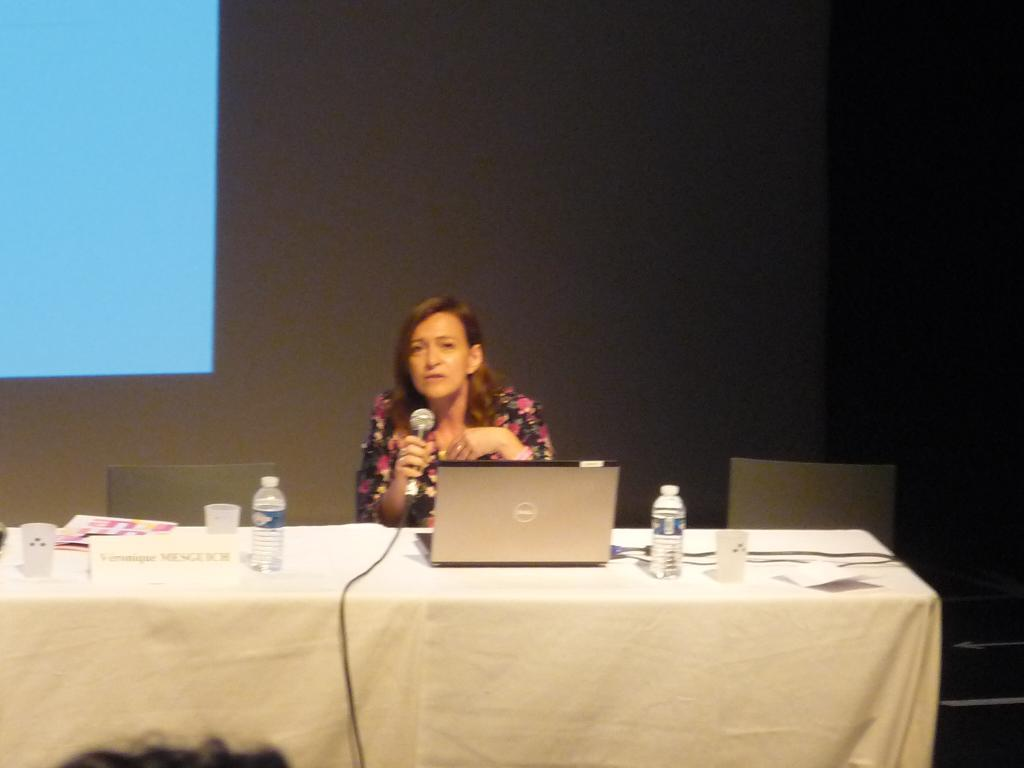What is the person in the image doing? The person is holding a microphone, which suggests they might be speaking or performing. What is the person wearing? The person is wearing a floral dress. What objects are in front of the person? There is a laptop, a water bottle, glasses, and an e. t. c. in front of the person. What type of arm is visible in the image? There is no arm visible in the image; the focus is on the person holding a microphone and the objects in front of them. 